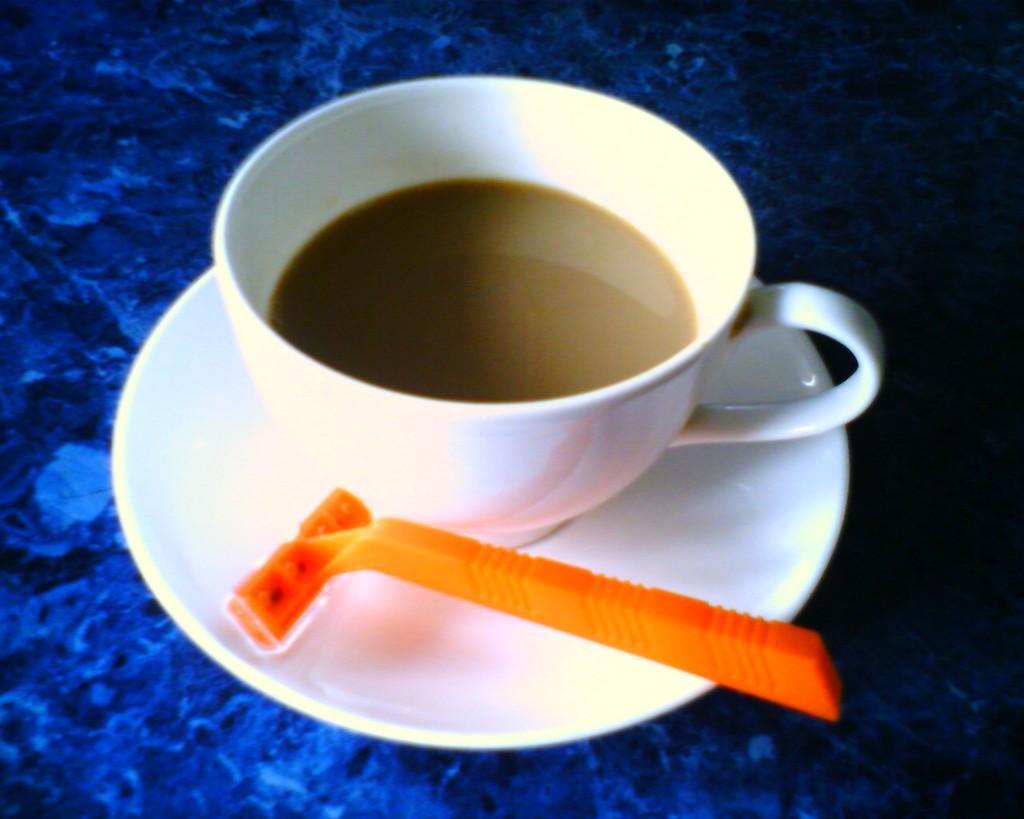Please provide a concise description of this image. In the center of the image, we can see a cup with saucer and there is a racer and the cup is filled with drink. At the bottom, there is table. 